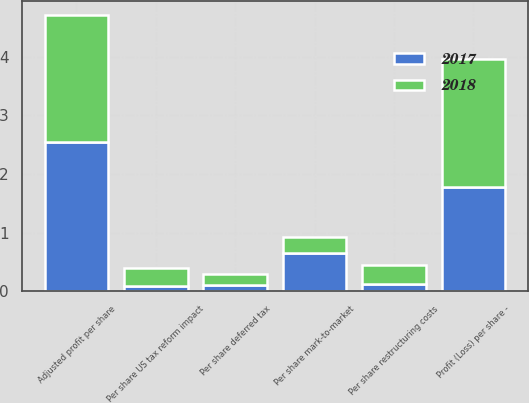Convert chart. <chart><loc_0><loc_0><loc_500><loc_500><stacked_bar_chart><ecel><fcel>Profit (Loss) per share -<fcel>Per share restructuring costs<fcel>Per share mark-to-market<fcel>Per share deferred tax<fcel>Per share US tax reform impact<fcel>Adjusted profit per share<nl><fcel>2017<fcel>1.78<fcel>0.13<fcel>0.66<fcel>0.11<fcel>0.09<fcel>2.55<nl><fcel>2018<fcel>2.18<fcel>0.31<fcel>0.26<fcel>0.18<fcel>0.31<fcel>2.16<nl></chart> 